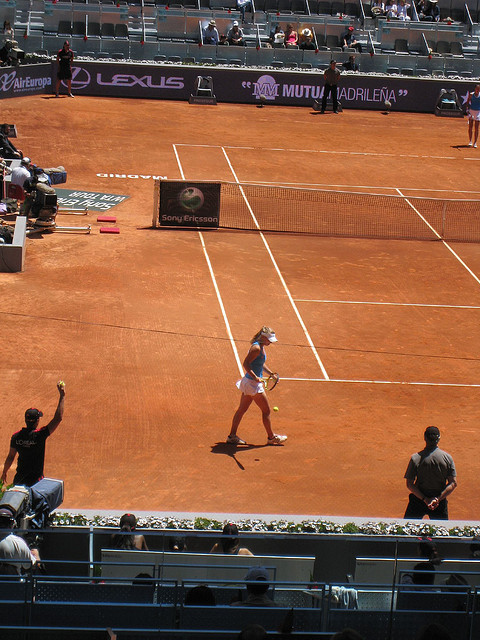Identify and read out the text in this image. sony Ericsson MM LEXUS AirEuropa 